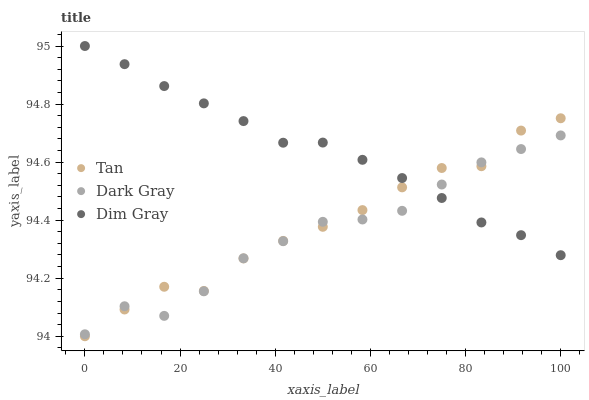Does Dark Gray have the minimum area under the curve?
Answer yes or no. Yes. Does Dim Gray have the maximum area under the curve?
Answer yes or no. Yes. Does Tan have the minimum area under the curve?
Answer yes or no. No. Does Tan have the maximum area under the curve?
Answer yes or no. No. Is Dim Gray the smoothest?
Answer yes or no. Yes. Is Tan the roughest?
Answer yes or no. Yes. Is Tan the smoothest?
Answer yes or no. No. Is Dim Gray the roughest?
Answer yes or no. No. Does Tan have the lowest value?
Answer yes or no. Yes. Does Dim Gray have the lowest value?
Answer yes or no. No. Does Dim Gray have the highest value?
Answer yes or no. Yes. Does Tan have the highest value?
Answer yes or no. No. Does Dark Gray intersect Dim Gray?
Answer yes or no. Yes. Is Dark Gray less than Dim Gray?
Answer yes or no. No. Is Dark Gray greater than Dim Gray?
Answer yes or no. No. 